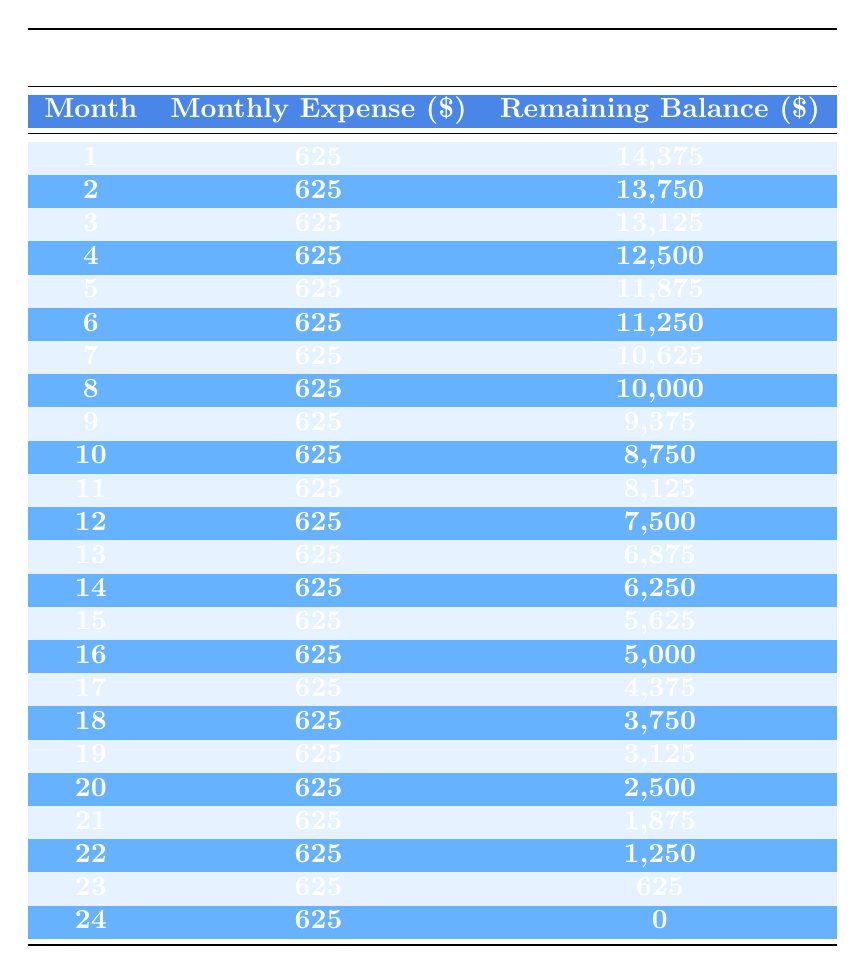What is the total cost of the photo shoot area setup? The table indicates a total cost of the photo shoot area setup as 15,000. This is stated at the beginning of the data under total cost.
Answer: 15000 What will the remaining balance be after the 12th month? Referring to the table, the remaining balance after the 12th month is provided in the monthly breakdown as 7,500.
Answer: 7500 Is the monthly expense consistent throughout the amortization period? The table shows a monthly expense of 625, and this value does not change in any of the months listed. Thus, it is indeed consistent.
Answer: Yes How much was spent on camera equipment compared to lighting setup? From the initial setup expenses, camera equipment costs 5,000 and lighting setup costs 3,000. The difference is 5,000 - 3,000 = 2,000.
Answer: 2000 What is the remaining balance at the end of the 6th month? Looking at the table, the remaining balance after the 6th month is listed as 11,250, which is obtained directly from the respective row.
Answer: 11250 What is the total expenses for months 1 through 3? For those months, the expense is 625 each month, so we calculate: 625 + 625 + 625 = 1,875. This gives us the total for the first three months.
Answer: 1875 After how many months will the remaining balance drop below 500? The table shows that the remaining balance will reach 625 at month 23 and drop to 0 at month 24. Therefore, it drops below 500 after the 23rd month.
Answer: 23 Is the expense for the last month the same as the previous months? The table indicates the expense remains 625 for all months, including the last month (24th). Thus, it is indeed the same.
Answer: Yes What is the average remaining balance at the end of the first 6 months? Summing the remaining balances for the first six months (14,375 + 13,750 + 13,125 + 12,500 + 11,875 + 11,250 = 77,875) and dividing by 6 gives an average of 12,978.
Answer: 12978 